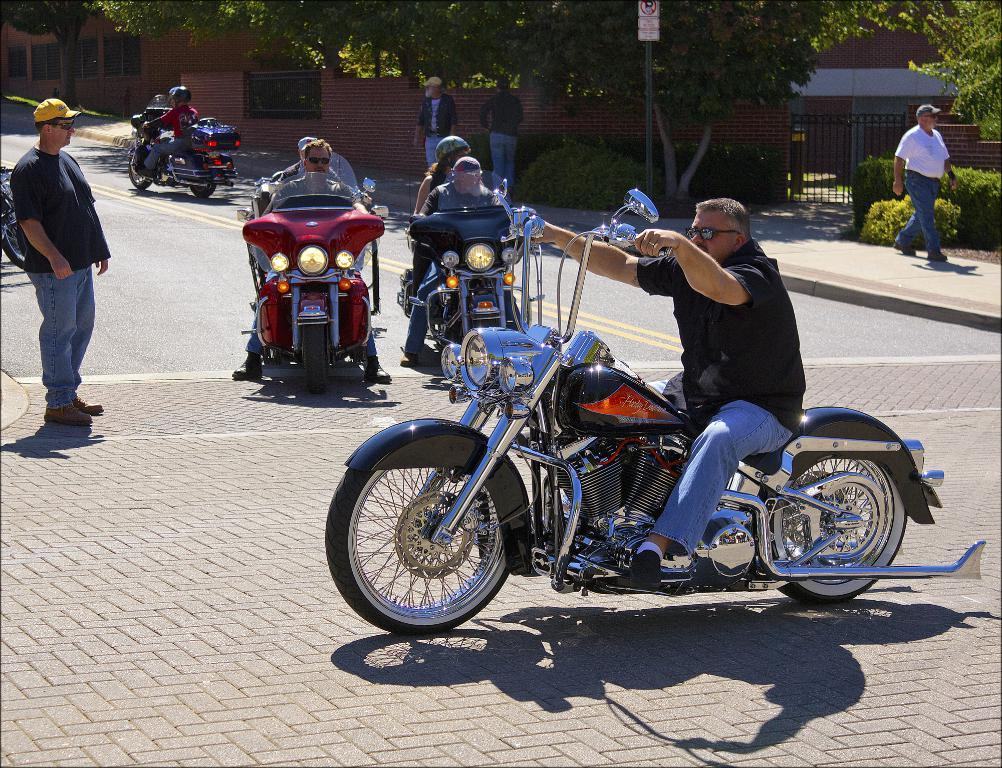What are the persons in the image doing? The persons in the image are riding bikes on a road. What is the man in the foreground doing? The man in the foreground is walking on a pathway. Can you describe the background of the image? There is a tree and a building visible in the background. How many men can be seen in the image? There are two men in the image, one walking and one standing in the background. What type of lead can be seen being produced in the image? There is no lead production or any reference to lead in the image. 